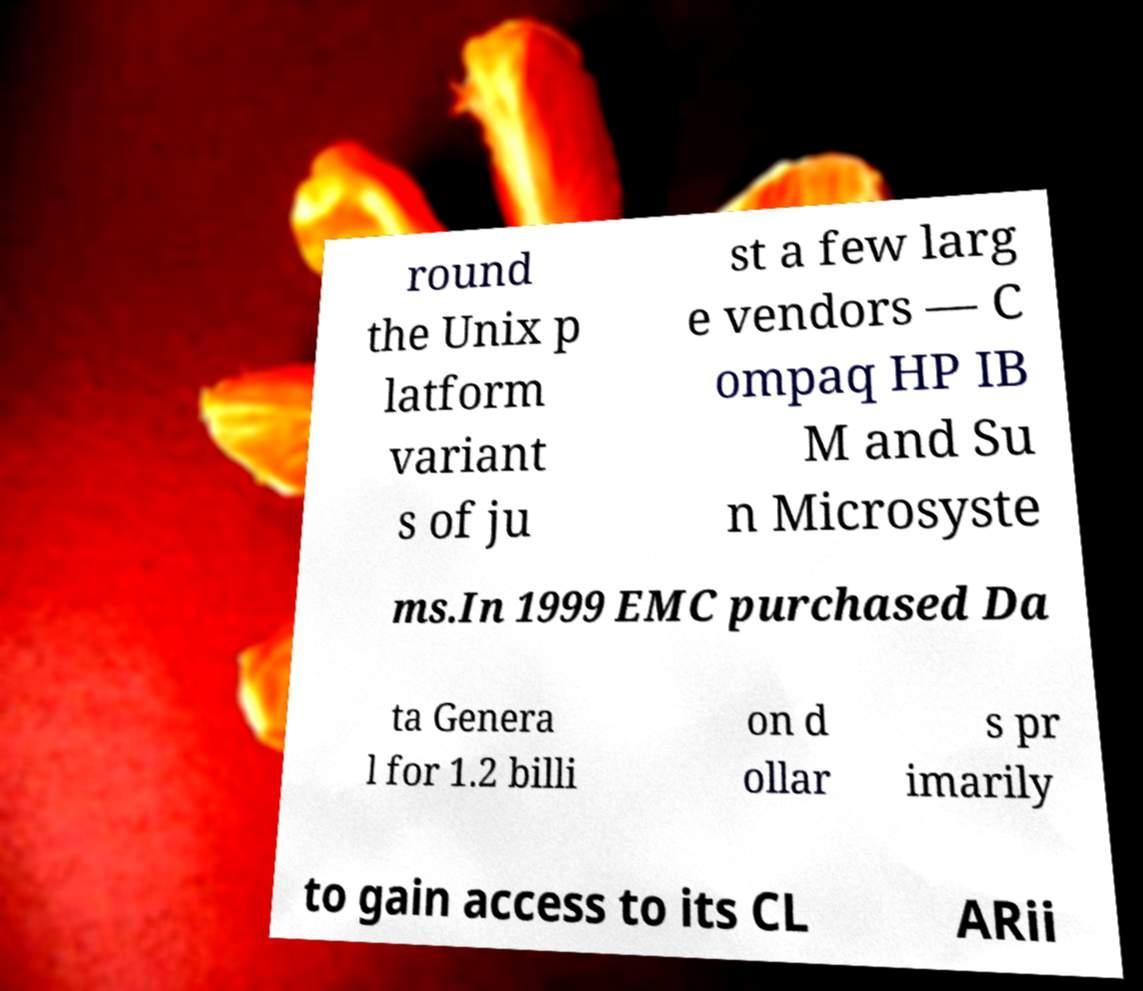There's text embedded in this image that I need extracted. Can you transcribe it verbatim? round the Unix p latform variant s of ju st a few larg e vendors — C ompaq HP IB M and Su n Microsyste ms.In 1999 EMC purchased Da ta Genera l for 1.2 billi on d ollar s pr imarily to gain access to its CL ARii 